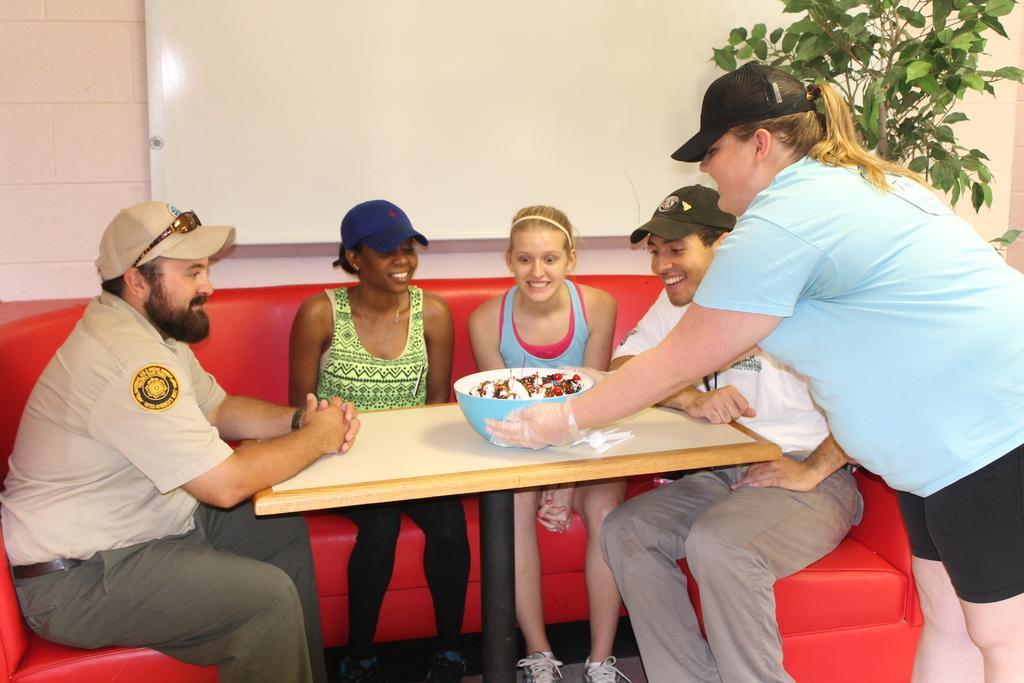In one or two sentences, can you explain what this image depicts? In this image, In the middle there is a table which is in yellow color on that table there is a bowl which is in blue color, There are some people sitting on the sofa which is in red color, In the background there is a white color board and in the right side there is a green color plant. 